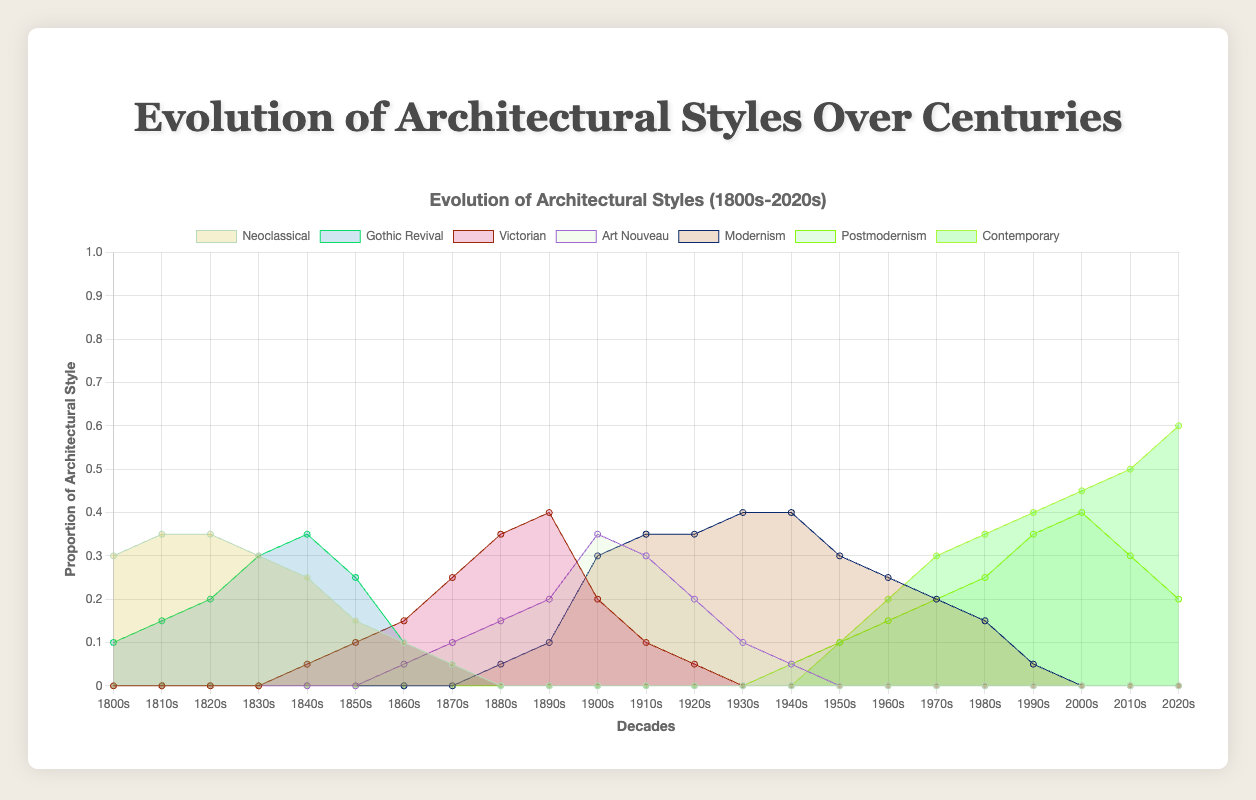What is the general trend of Neoclassical style over the decades? The Neoclassical style starts at 0.3 in the 1800s and peaks at 0.35 in the 1810s and 1820s. It then gradually declines and disappears by the 1870s.
Answer: It declines over time Which architectural style dominates the 1900s? In the 1900s, Neoclassical and Gothic Revival have already disappeared. Victorian starts to decline, reaching around 0.2, while Art Nouveau peaks at 0.35 and Modernism starts emerging. Art Nouveau is the most dominant style.
Answer: Art Nouveau Between the 1830s and the 1840s, which style increased the most? During this period, Gothic Revival increases from 0.30 to 0.35, while Neoclassical decreases, and Victorian is still emerging slightly. Gothic Revival has the most significant increase.
Answer: Gothic Revival What can you infer about the trend of Contemporary architecture post-2000s? Contemporary architecture starts at 0.1 in the 1950s and consistently increases, reaching 0.6 by the 2020s, indicating a continuous growth, especially notable after the 2000s.
Answer: Continuous growth When does Modernism reach its peak proportion? Modernism is most prevalent between the 1930s and 1950s, peaking at 0.4 in these decades.
Answer: 1930s to 1950s How does the proportion of Victorian style change from the 1840s to the 1890s? Victorian starts at 0.05 in the 1840s, increases to 0.4 by the 1890s, hitting its peak.
Answer: It increases to a peak Which style has the highest proportion in the 1980s, and what is it? In the 1980s, Contemporary architecture and Postmodernism are rising. Postmodernism reaches 0.25, Contemporary is at 0.35, making it the highest proportion.
Answer: Contemporary at 0.35 Compare the trends of Art Nouveau and Modernism from the 1910s to the 1940s. Art Nouveau decreases from 0.30 in the 1910s to 0.05 by the 1940s, while Modernism significantly rises from 0.30 to 0.40 during the same period.
Answer: Art Nouveau declines, Modernism rises Which style first appears in the dataset and when does it peak? Neoclassical is the earliest style, appearing at 0.3 in the 1800s and peaking slightly at 0.35 in the 1810s and 1820s.
Answer: Neoclassical in 1810s and 1820s 